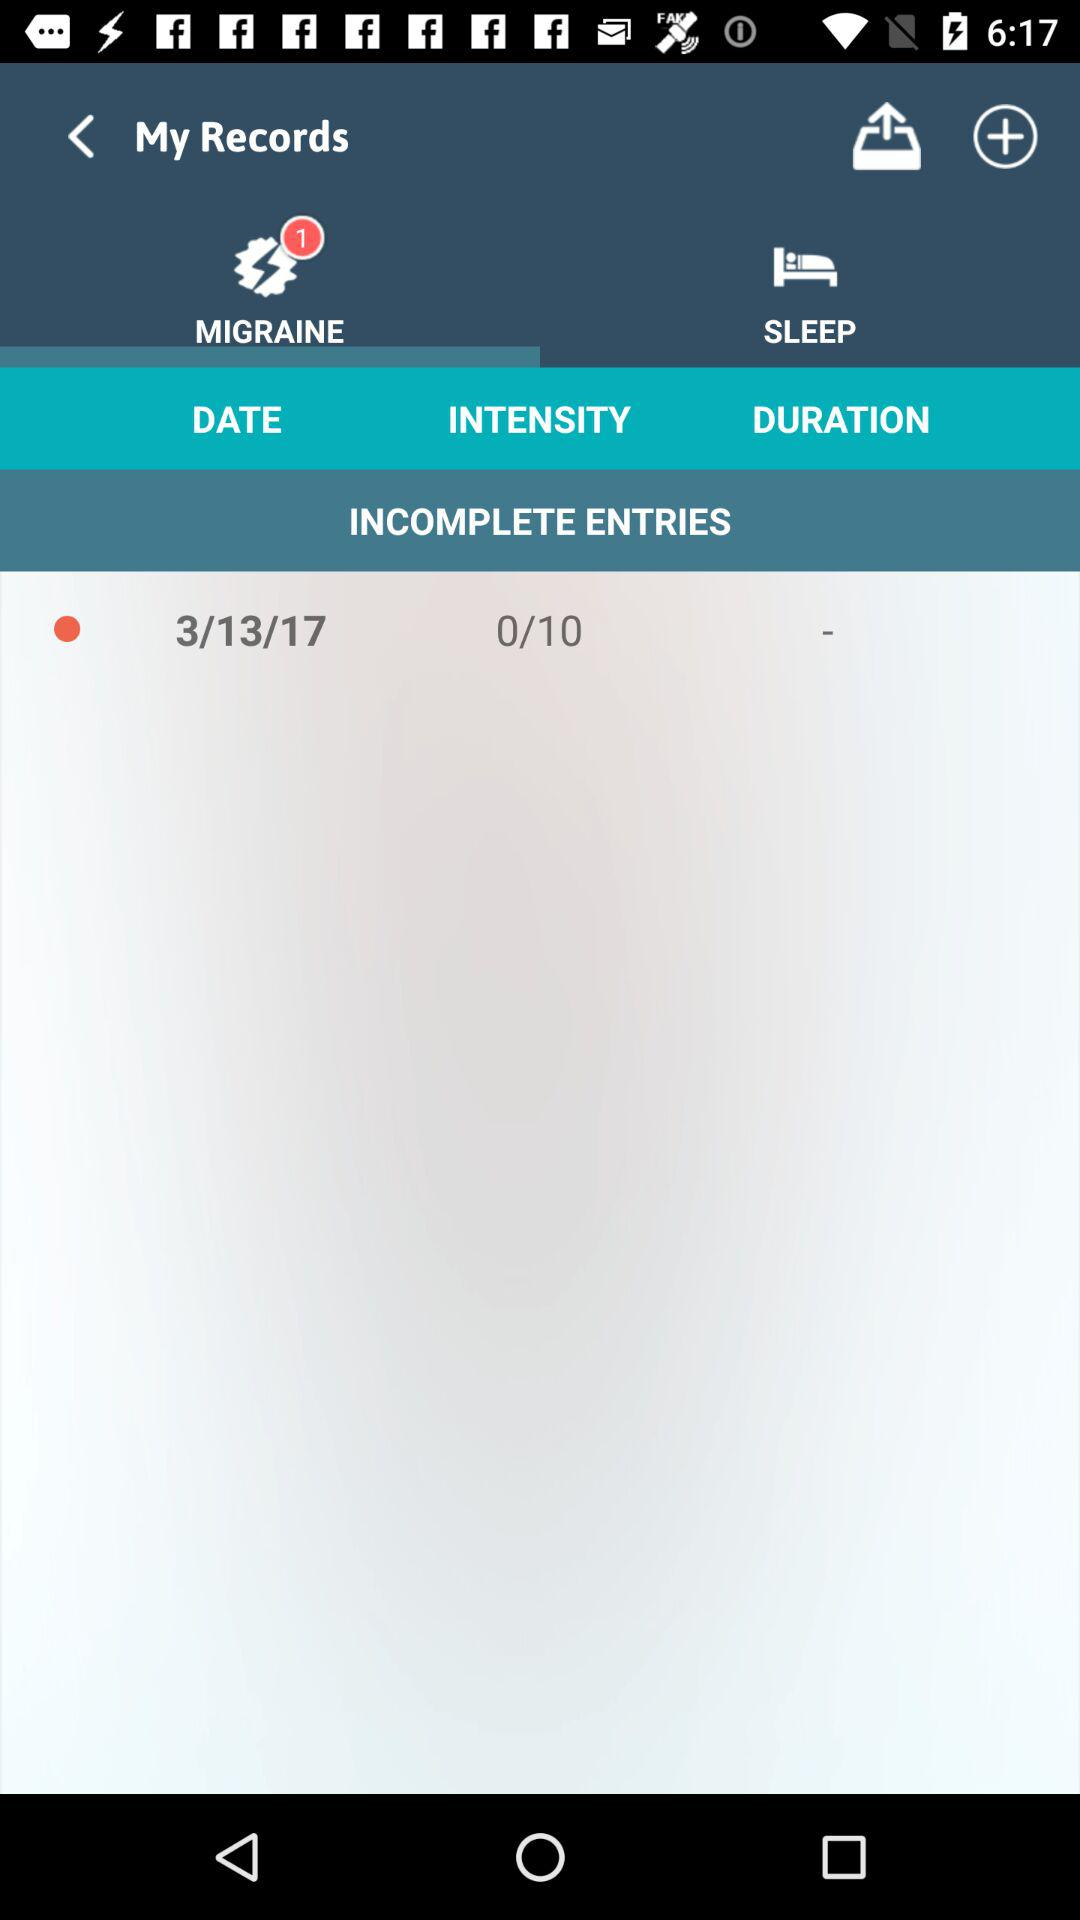How many entries are incomplete?
Answer the question using a single word or phrase. 1 